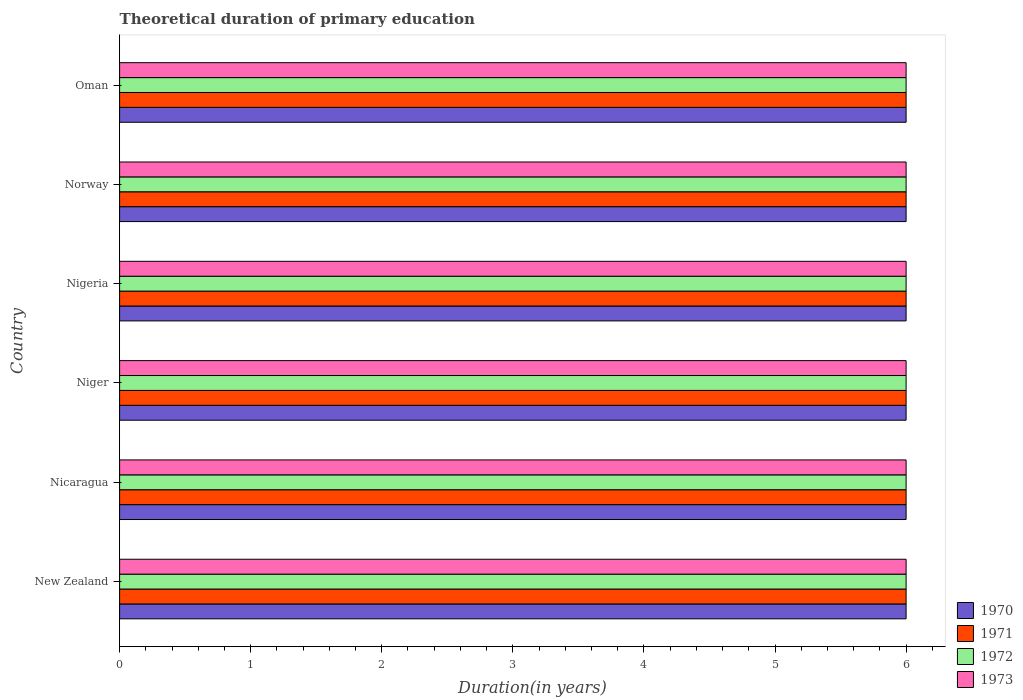How many different coloured bars are there?
Provide a succinct answer. 4. How many groups of bars are there?
Offer a very short reply. 6. Are the number of bars per tick equal to the number of legend labels?
Your response must be concise. Yes. How many bars are there on the 5th tick from the top?
Your answer should be very brief. 4. How many bars are there on the 6th tick from the bottom?
Keep it short and to the point. 4. What is the label of the 1st group of bars from the top?
Ensure brevity in your answer.  Oman. What is the total theoretical duration of primary education in 1970 in Nicaragua?
Offer a terse response. 6. Across all countries, what is the minimum total theoretical duration of primary education in 1973?
Give a very brief answer. 6. In which country was the total theoretical duration of primary education in 1971 maximum?
Your answer should be very brief. New Zealand. In which country was the total theoretical duration of primary education in 1971 minimum?
Provide a short and direct response. New Zealand. What is the total total theoretical duration of primary education in 1973 in the graph?
Provide a succinct answer. 36. What is the average total theoretical duration of primary education in 1973 per country?
Offer a very short reply. 6. What is the difference between the total theoretical duration of primary education in 1973 and total theoretical duration of primary education in 1970 in Niger?
Your answer should be compact. 0. Is the difference between the total theoretical duration of primary education in 1973 in New Zealand and Oman greater than the difference between the total theoretical duration of primary education in 1970 in New Zealand and Oman?
Give a very brief answer. No. What is the difference between the highest and the lowest total theoretical duration of primary education in 1971?
Provide a succinct answer. 0. In how many countries, is the total theoretical duration of primary education in 1972 greater than the average total theoretical duration of primary education in 1972 taken over all countries?
Give a very brief answer. 0. Is the sum of the total theoretical duration of primary education in 1972 in New Zealand and Oman greater than the maximum total theoretical duration of primary education in 1971 across all countries?
Give a very brief answer. Yes. Is it the case that in every country, the sum of the total theoretical duration of primary education in 1973 and total theoretical duration of primary education in 1971 is greater than the sum of total theoretical duration of primary education in 1972 and total theoretical duration of primary education in 1970?
Ensure brevity in your answer.  No. What does the 4th bar from the top in New Zealand represents?
Your response must be concise. 1970. How many bars are there?
Make the answer very short. 24. How many countries are there in the graph?
Make the answer very short. 6. What is the difference between two consecutive major ticks on the X-axis?
Keep it short and to the point. 1. Does the graph contain any zero values?
Keep it short and to the point. No. Does the graph contain grids?
Your answer should be compact. No. Where does the legend appear in the graph?
Provide a short and direct response. Bottom right. How many legend labels are there?
Your answer should be very brief. 4. How are the legend labels stacked?
Make the answer very short. Vertical. What is the title of the graph?
Your answer should be very brief. Theoretical duration of primary education. Does "2009" appear as one of the legend labels in the graph?
Ensure brevity in your answer.  No. What is the label or title of the X-axis?
Make the answer very short. Duration(in years). What is the label or title of the Y-axis?
Your answer should be compact. Country. What is the Duration(in years) of 1973 in Nicaragua?
Keep it short and to the point. 6. What is the Duration(in years) of 1970 in Niger?
Keep it short and to the point. 6. What is the Duration(in years) of 1973 in Niger?
Offer a very short reply. 6. What is the Duration(in years) in 1970 in Nigeria?
Your answer should be compact. 6. What is the Duration(in years) in 1973 in Nigeria?
Your answer should be very brief. 6. What is the Duration(in years) in 1972 in Norway?
Offer a terse response. 6. What is the Duration(in years) in 1973 in Norway?
Offer a very short reply. 6. What is the Duration(in years) in 1970 in Oman?
Your answer should be compact. 6. What is the Duration(in years) of 1971 in Oman?
Ensure brevity in your answer.  6. What is the Duration(in years) in 1973 in Oman?
Give a very brief answer. 6. Across all countries, what is the maximum Duration(in years) of 1970?
Offer a terse response. 6. Across all countries, what is the minimum Duration(in years) of 1973?
Your answer should be very brief. 6. What is the difference between the Duration(in years) in 1971 in New Zealand and that in Nicaragua?
Keep it short and to the point. 0. What is the difference between the Duration(in years) in 1970 in New Zealand and that in Niger?
Your answer should be compact. 0. What is the difference between the Duration(in years) of 1971 in New Zealand and that in Niger?
Your response must be concise. 0. What is the difference between the Duration(in years) of 1973 in New Zealand and that in Niger?
Offer a terse response. 0. What is the difference between the Duration(in years) of 1971 in New Zealand and that in Nigeria?
Your response must be concise. 0. What is the difference between the Duration(in years) in 1973 in New Zealand and that in Nigeria?
Give a very brief answer. 0. What is the difference between the Duration(in years) in 1971 in New Zealand and that in Norway?
Ensure brevity in your answer.  0. What is the difference between the Duration(in years) in 1972 in New Zealand and that in Norway?
Your response must be concise. 0. What is the difference between the Duration(in years) of 1973 in New Zealand and that in Norway?
Make the answer very short. 0. What is the difference between the Duration(in years) in 1970 in New Zealand and that in Oman?
Your answer should be very brief. 0. What is the difference between the Duration(in years) of 1971 in New Zealand and that in Oman?
Offer a very short reply. 0. What is the difference between the Duration(in years) in 1972 in New Zealand and that in Oman?
Give a very brief answer. 0. What is the difference between the Duration(in years) in 1973 in New Zealand and that in Oman?
Offer a terse response. 0. What is the difference between the Duration(in years) of 1970 in Nicaragua and that in Niger?
Your answer should be very brief. 0. What is the difference between the Duration(in years) in 1971 in Nicaragua and that in Niger?
Provide a short and direct response. 0. What is the difference between the Duration(in years) of 1973 in Nicaragua and that in Niger?
Ensure brevity in your answer.  0. What is the difference between the Duration(in years) in 1971 in Nicaragua and that in Nigeria?
Give a very brief answer. 0. What is the difference between the Duration(in years) in 1972 in Nicaragua and that in Oman?
Ensure brevity in your answer.  0. What is the difference between the Duration(in years) in 1973 in Nicaragua and that in Oman?
Offer a very short reply. 0. What is the difference between the Duration(in years) of 1970 in Niger and that in Norway?
Ensure brevity in your answer.  0. What is the difference between the Duration(in years) in 1971 in Niger and that in Norway?
Offer a very short reply. 0. What is the difference between the Duration(in years) in 1972 in Niger and that in Norway?
Keep it short and to the point. 0. What is the difference between the Duration(in years) of 1973 in Niger and that in Norway?
Offer a terse response. 0. What is the difference between the Duration(in years) in 1970 in Niger and that in Oman?
Keep it short and to the point. 0. What is the difference between the Duration(in years) of 1971 in Niger and that in Oman?
Provide a short and direct response. 0. What is the difference between the Duration(in years) of 1973 in Niger and that in Oman?
Provide a succinct answer. 0. What is the difference between the Duration(in years) in 1973 in Nigeria and that in Norway?
Provide a succinct answer. 0. What is the difference between the Duration(in years) of 1972 in Norway and that in Oman?
Make the answer very short. 0. What is the difference between the Duration(in years) of 1970 in New Zealand and the Duration(in years) of 1971 in Nicaragua?
Offer a very short reply. 0. What is the difference between the Duration(in years) of 1970 in New Zealand and the Duration(in years) of 1973 in Nicaragua?
Offer a terse response. 0. What is the difference between the Duration(in years) of 1970 in New Zealand and the Duration(in years) of 1971 in Niger?
Your answer should be very brief. 0. What is the difference between the Duration(in years) in 1970 in New Zealand and the Duration(in years) in 1972 in Niger?
Your answer should be very brief. 0. What is the difference between the Duration(in years) of 1970 in New Zealand and the Duration(in years) of 1973 in Niger?
Your answer should be compact. 0. What is the difference between the Duration(in years) of 1971 in New Zealand and the Duration(in years) of 1972 in Niger?
Your answer should be compact. 0. What is the difference between the Duration(in years) of 1970 in New Zealand and the Duration(in years) of 1973 in Nigeria?
Give a very brief answer. 0. What is the difference between the Duration(in years) in 1971 in New Zealand and the Duration(in years) in 1973 in Nigeria?
Your response must be concise. 0. What is the difference between the Duration(in years) in 1972 in New Zealand and the Duration(in years) in 1973 in Nigeria?
Give a very brief answer. 0. What is the difference between the Duration(in years) of 1971 in New Zealand and the Duration(in years) of 1973 in Norway?
Keep it short and to the point. 0. What is the difference between the Duration(in years) of 1970 in New Zealand and the Duration(in years) of 1971 in Oman?
Offer a terse response. 0. What is the difference between the Duration(in years) of 1970 in New Zealand and the Duration(in years) of 1972 in Oman?
Keep it short and to the point. 0. What is the difference between the Duration(in years) of 1971 in New Zealand and the Duration(in years) of 1973 in Oman?
Provide a short and direct response. 0. What is the difference between the Duration(in years) in 1971 in Nicaragua and the Duration(in years) in 1972 in Niger?
Your answer should be compact. 0. What is the difference between the Duration(in years) in 1972 in Nicaragua and the Duration(in years) in 1973 in Niger?
Your answer should be very brief. 0. What is the difference between the Duration(in years) of 1970 in Nicaragua and the Duration(in years) of 1971 in Nigeria?
Ensure brevity in your answer.  0. What is the difference between the Duration(in years) in 1970 in Nicaragua and the Duration(in years) in 1972 in Nigeria?
Keep it short and to the point. 0. What is the difference between the Duration(in years) of 1971 in Nicaragua and the Duration(in years) of 1972 in Nigeria?
Your answer should be very brief. 0. What is the difference between the Duration(in years) in 1971 in Nicaragua and the Duration(in years) in 1973 in Nigeria?
Keep it short and to the point. 0. What is the difference between the Duration(in years) in 1972 in Nicaragua and the Duration(in years) in 1973 in Nigeria?
Your answer should be very brief. 0. What is the difference between the Duration(in years) in 1970 in Nicaragua and the Duration(in years) in 1971 in Norway?
Provide a short and direct response. 0. What is the difference between the Duration(in years) in 1971 in Nicaragua and the Duration(in years) in 1972 in Norway?
Ensure brevity in your answer.  0. What is the difference between the Duration(in years) in 1972 in Nicaragua and the Duration(in years) in 1973 in Norway?
Give a very brief answer. 0. What is the difference between the Duration(in years) of 1970 in Nicaragua and the Duration(in years) of 1972 in Oman?
Your answer should be very brief. 0. What is the difference between the Duration(in years) in 1971 in Nicaragua and the Duration(in years) in 1973 in Oman?
Your response must be concise. 0. What is the difference between the Duration(in years) in 1970 in Niger and the Duration(in years) in 1972 in Nigeria?
Keep it short and to the point. 0. What is the difference between the Duration(in years) in 1970 in Niger and the Duration(in years) in 1973 in Nigeria?
Offer a very short reply. 0. What is the difference between the Duration(in years) in 1971 in Niger and the Duration(in years) in 1972 in Nigeria?
Keep it short and to the point. 0. What is the difference between the Duration(in years) in 1970 in Niger and the Duration(in years) in 1971 in Norway?
Give a very brief answer. 0. What is the difference between the Duration(in years) of 1970 in Niger and the Duration(in years) of 1972 in Norway?
Provide a short and direct response. 0. What is the difference between the Duration(in years) of 1970 in Niger and the Duration(in years) of 1973 in Norway?
Your answer should be very brief. 0. What is the difference between the Duration(in years) of 1971 in Niger and the Duration(in years) of 1972 in Norway?
Ensure brevity in your answer.  0. What is the difference between the Duration(in years) of 1971 in Niger and the Duration(in years) of 1973 in Norway?
Provide a succinct answer. 0. What is the difference between the Duration(in years) of 1970 in Niger and the Duration(in years) of 1971 in Oman?
Give a very brief answer. 0. What is the difference between the Duration(in years) of 1970 in Niger and the Duration(in years) of 1972 in Oman?
Provide a short and direct response. 0. What is the difference between the Duration(in years) of 1971 in Niger and the Duration(in years) of 1972 in Oman?
Provide a succinct answer. 0. What is the difference between the Duration(in years) in 1971 in Niger and the Duration(in years) in 1973 in Oman?
Provide a succinct answer. 0. What is the difference between the Duration(in years) in 1971 in Nigeria and the Duration(in years) in 1972 in Norway?
Make the answer very short. 0. What is the difference between the Duration(in years) in 1971 in Nigeria and the Duration(in years) in 1973 in Norway?
Provide a short and direct response. 0. What is the difference between the Duration(in years) in 1970 in Nigeria and the Duration(in years) in 1971 in Oman?
Your answer should be compact. 0. What is the difference between the Duration(in years) of 1970 in Nigeria and the Duration(in years) of 1972 in Oman?
Ensure brevity in your answer.  0. What is the difference between the Duration(in years) of 1970 in Nigeria and the Duration(in years) of 1973 in Oman?
Offer a terse response. 0. What is the difference between the Duration(in years) in 1971 in Nigeria and the Duration(in years) in 1972 in Oman?
Your response must be concise. 0. What is the difference between the Duration(in years) in 1971 in Nigeria and the Duration(in years) in 1973 in Oman?
Offer a terse response. 0. What is the difference between the Duration(in years) in 1972 in Nigeria and the Duration(in years) in 1973 in Oman?
Give a very brief answer. 0. What is the difference between the Duration(in years) of 1970 in Norway and the Duration(in years) of 1971 in Oman?
Your answer should be very brief. 0. What is the difference between the Duration(in years) of 1970 in Norway and the Duration(in years) of 1972 in Oman?
Your answer should be compact. 0. What is the difference between the Duration(in years) of 1970 in Norway and the Duration(in years) of 1973 in Oman?
Give a very brief answer. 0. What is the difference between the Duration(in years) of 1971 in Norway and the Duration(in years) of 1972 in Oman?
Offer a terse response. 0. What is the difference between the Duration(in years) in 1971 in Norway and the Duration(in years) in 1973 in Oman?
Your answer should be very brief. 0. What is the difference between the Duration(in years) of 1972 in Norway and the Duration(in years) of 1973 in Oman?
Your answer should be very brief. 0. What is the difference between the Duration(in years) in 1970 and Duration(in years) in 1971 in New Zealand?
Provide a succinct answer. 0. What is the difference between the Duration(in years) of 1970 and Duration(in years) of 1972 in New Zealand?
Your response must be concise. 0. What is the difference between the Duration(in years) in 1970 and Duration(in years) in 1973 in New Zealand?
Keep it short and to the point. 0. What is the difference between the Duration(in years) in 1971 and Duration(in years) in 1973 in New Zealand?
Offer a very short reply. 0. What is the difference between the Duration(in years) in 1972 and Duration(in years) in 1973 in New Zealand?
Provide a short and direct response. 0. What is the difference between the Duration(in years) of 1970 and Duration(in years) of 1971 in Nicaragua?
Offer a very short reply. 0. What is the difference between the Duration(in years) in 1971 and Duration(in years) in 1973 in Nicaragua?
Your answer should be compact. 0. What is the difference between the Duration(in years) in 1972 and Duration(in years) in 1973 in Nicaragua?
Provide a short and direct response. 0. What is the difference between the Duration(in years) in 1970 and Duration(in years) in 1973 in Niger?
Provide a succinct answer. 0. What is the difference between the Duration(in years) in 1972 and Duration(in years) in 1973 in Niger?
Keep it short and to the point. 0. What is the difference between the Duration(in years) of 1970 and Duration(in years) of 1971 in Nigeria?
Provide a short and direct response. 0. What is the difference between the Duration(in years) of 1970 and Duration(in years) of 1972 in Nigeria?
Make the answer very short. 0. What is the difference between the Duration(in years) in 1970 and Duration(in years) in 1973 in Nigeria?
Keep it short and to the point. 0. What is the difference between the Duration(in years) in 1971 and Duration(in years) in 1973 in Nigeria?
Keep it short and to the point. 0. What is the difference between the Duration(in years) of 1970 and Duration(in years) of 1971 in Norway?
Make the answer very short. 0. What is the difference between the Duration(in years) in 1970 and Duration(in years) in 1973 in Oman?
Provide a succinct answer. 0. What is the difference between the Duration(in years) in 1971 and Duration(in years) in 1972 in Oman?
Provide a succinct answer. 0. What is the difference between the Duration(in years) in 1971 and Duration(in years) in 1973 in Oman?
Your answer should be very brief. 0. What is the difference between the Duration(in years) of 1972 and Duration(in years) of 1973 in Oman?
Keep it short and to the point. 0. What is the ratio of the Duration(in years) in 1971 in New Zealand to that in Nicaragua?
Your response must be concise. 1. What is the ratio of the Duration(in years) of 1972 in New Zealand to that in Nicaragua?
Provide a short and direct response. 1. What is the ratio of the Duration(in years) of 1973 in New Zealand to that in Nicaragua?
Provide a succinct answer. 1. What is the ratio of the Duration(in years) of 1971 in New Zealand to that in Niger?
Your response must be concise. 1. What is the ratio of the Duration(in years) in 1972 in New Zealand to that in Niger?
Ensure brevity in your answer.  1. What is the ratio of the Duration(in years) in 1973 in New Zealand to that in Niger?
Ensure brevity in your answer.  1. What is the ratio of the Duration(in years) in 1972 in New Zealand to that in Nigeria?
Make the answer very short. 1. What is the ratio of the Duration(in years) of 1973 in New Zealand to that in Nigeria?
Your answer should be very brief. 1. What is the ratio of the Duration(in years) in 1971 in New Zealand to that in Norway?
Give a very brief answer. 1. What is the ratio of the Duration(in years) of 1972 in New Zealand to that in Norway?
Keep it short and to the point. 1. What is the ratio of the Duration(in years) in 1972 in New Zealand to that in Oman?
Your answer should be very brief. 1. What is the ratio of the Duration(in years) in 1973 in New Zealand to that in Oman?
Provide a succinct answer. 1. What is the ratio of the Duration(in years) of 1970 in Nicaragua to that in Niger?
Ensure brevity in your answer.  1. What is the ratio of the Duration(in years) in 1972 in Nicaragua to that in Niger?
Give a very brief answer. 1. What is the ratio of the Duration(in years) of 1971 in Nicaragua to that in Nigeria?
Your answer should be compact. 1. What is the ratio of the Duration(in years) of 1973 in Nicaragua to that in Nigeria?
Keep it short and to the point. 1. What is the ratio of the Duration(in years) in 1970 in Nicaragua to that in Oman?
Make the answer very short. 1. What is the ratio of the Duration(in years) in 1970 in Niger to that in Nigeria?
Provide a succinct answer. 1. What is the ratio of the Duration(in years) of 1971 in Niger to that in Norway?
Your answer should be compact. 1. What is the ratio of the Duration(in years) in 1972 in Niger to that in Oman?
Offer a very short reply. 1. What is the ratio of the Duration(in years) of 1970 in Nigeria to that in Norway?
Offer a terse response. 1. What is the ratio of the Duration(in years) in 1972 in Nigeria to that in Norway?
Your response must be concise. 1. What is the ratio of the Duration(in years) of 1970 in Nigeria to that in Oman?
Keep it short and to the point. 1. What is the ratio of the Duration(in years) in 1972 in Nigeria to that in Oman?
Provide a succinct answer. 1. What is the ratio of the Duration(in years) of 1973 in Norway to that in Oman?
Your response must be concise. 1. What is the difference between the highest and the second highest Duration(in years) of 1970?
Keep it short and to the point. 0. What is the difference between the highest and the second highest Duration(in years) of 1971?
Give a very brief answer. 0. What is the difference between the highest and the lowest Duration(in years) in 1970?
Provide a succinct answer. 0. What is the difference between the highest and the lowest Duration(in years) of 1971?
Ensure brevity in your answer.  0. What is the difference between the highest and the lowest Duration(in years) of 1973?
Offer a very short reply. 0. 